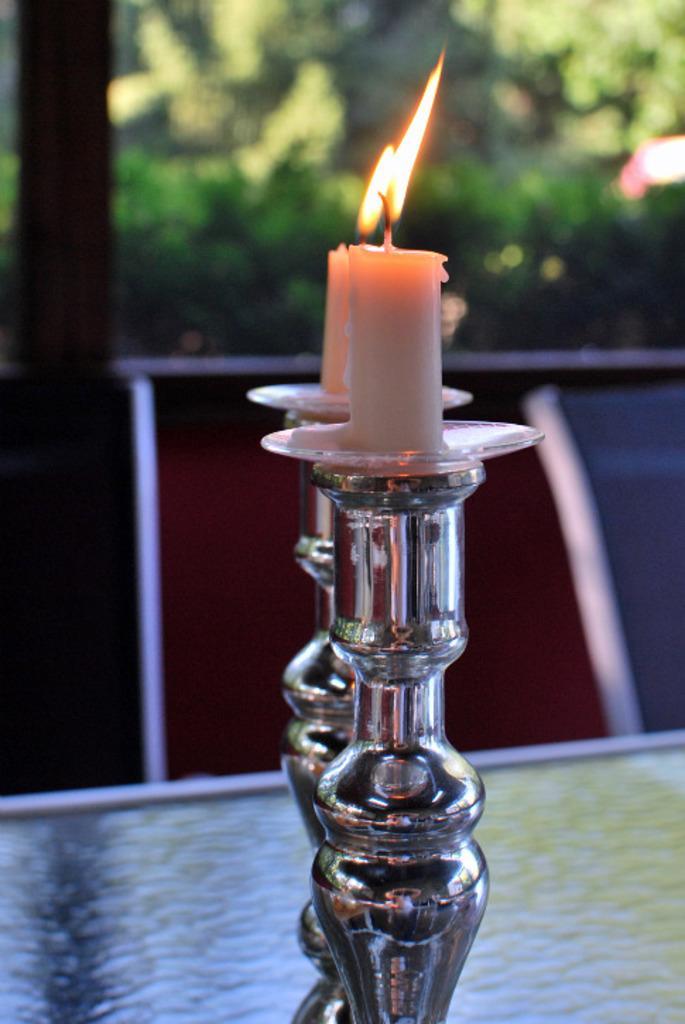Describe this image in one or two sentences. In this picture we can see two candles placed on stands and these stunts are placed on a platform and in the background we can see trees. 